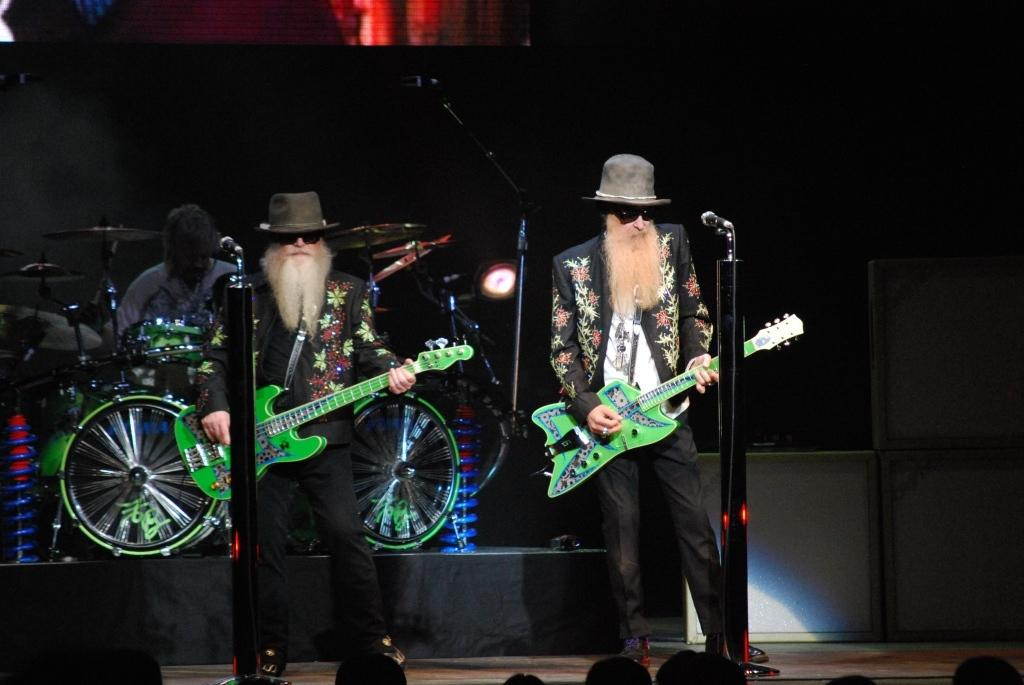What is the person in the image wearing? The person is wearing a black suit in the image. What is the person doing while wearing the black suit? The person is playing a guitar. What object is in front of the person playing the guitar? There is a microphone in front of the person playing the guitar. What is the other person in the image doing? The other person in the background is playing drums. Who is present in front of the musicians? There are audience members in front of the musicians. What type of bubble is floating around the person playing the guitar? There is no bubble present in the image; it is a person playing a guitar and wearing a black suit. 